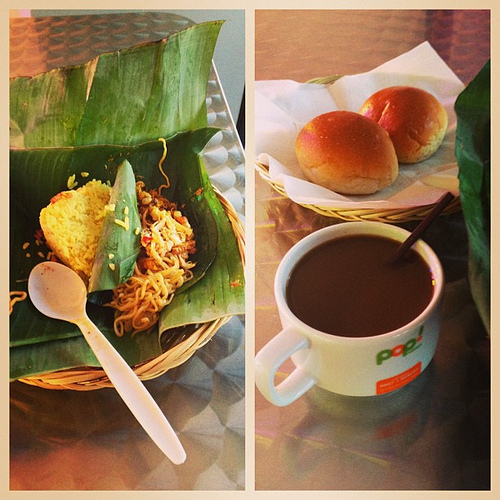If you were to add one more dish to this meal, what would complement it? To balance out the meal, a fresh salad with crisp greens and a zesty dressing would add both color and a refreshing contrast in flavors and textures to the warm noodles and bread buns, completing the dining experience with a touch of freshness. 